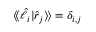Convert formula to latex. <formula><loc_0><loc_0><loc_500><loc_500>\langle \, \langle \hat { \ell } _ { i } | \hat { r } _ { j } \rangle \, \rangle = \delta _ { i , j }</formula> 